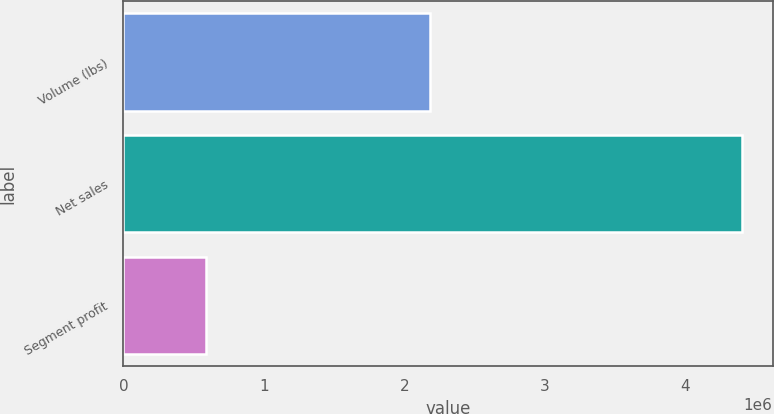<chart> <loc_0><loc_0><loc_500><loc_500><bar_chart><fcel>Volume (lbs)<fcel>Net sales<fcel>Segment profit<nl><fcel>2.18041e+06<fcel>4.40373e+06<fcel>587929<nl></chart> 